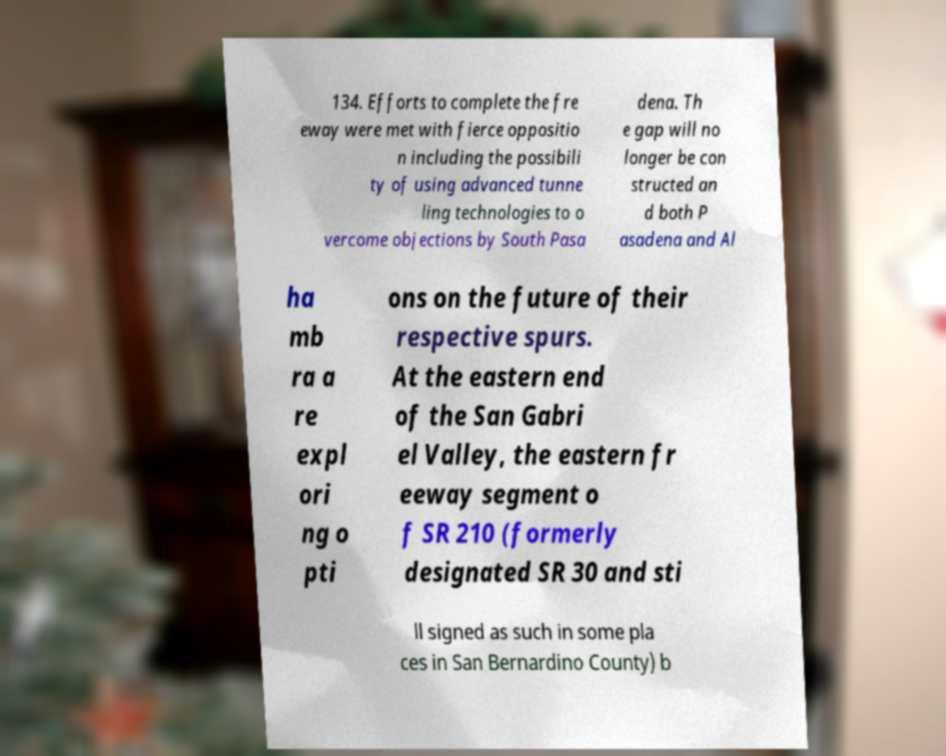Can you accurately transcribe the text from the provided image for me? 134. Efforts to complete the fre eway were met with fierce oppositio n including the possibili ty of using advanced tunne ling technologies to o vercome objections by South Pasa dena. Th e gap will no longer be con structed an d both P asadena and Al ha mb ra a re expl ori ng o pti ons on the future of their respective spurs. At the eastern end of the San Gabri el Valley, the eastern fr eeway segment o f SR 210 (formerly designated SR 30 and sti ll signed as such in some pla ces in San Bernardino County) b 